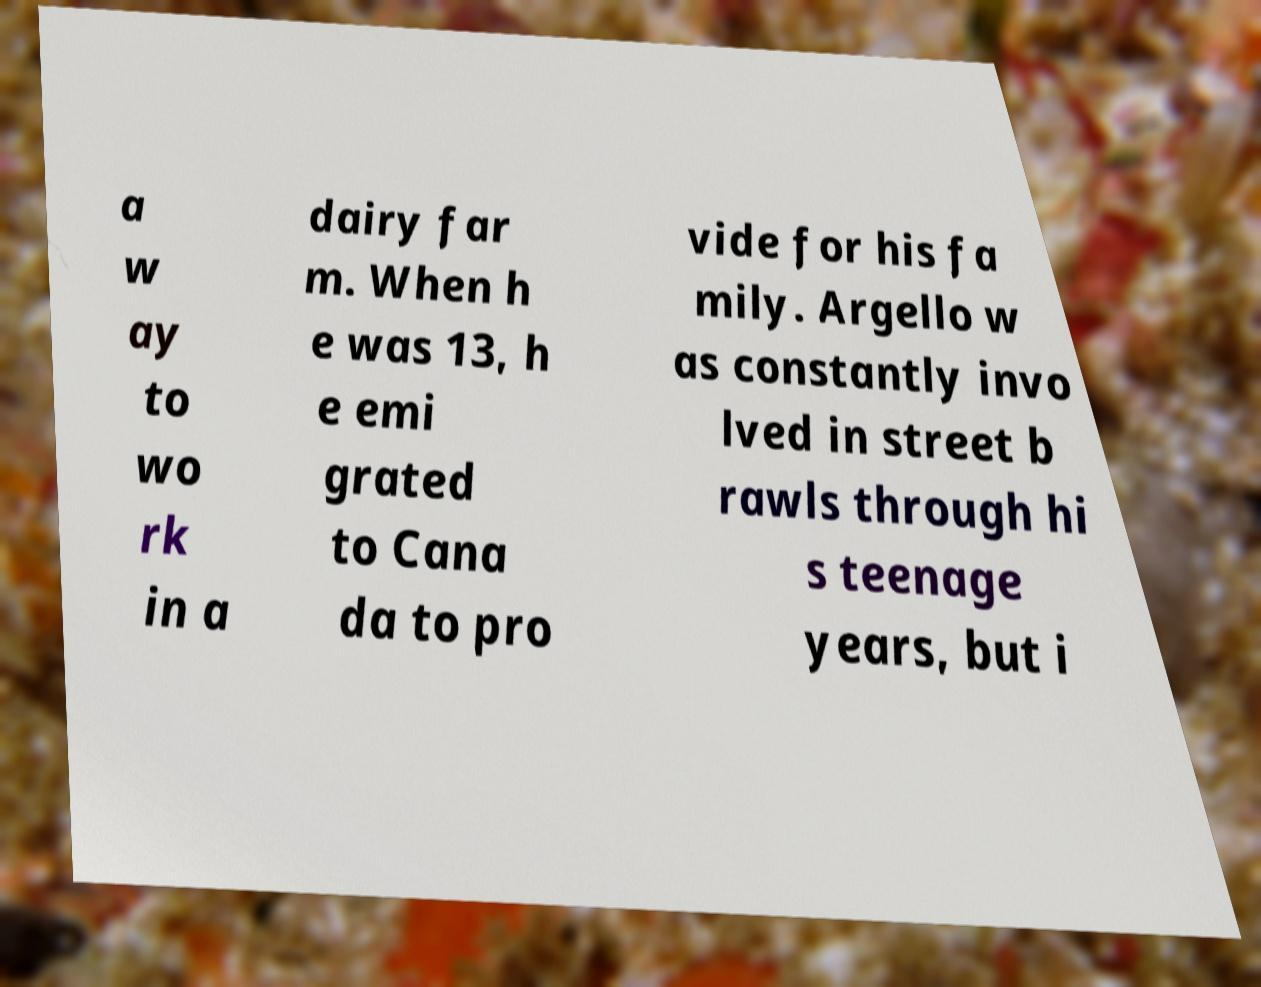There's text embedded in this image that I need extracted. Can you transcribe it verbatim? a w ay to wo rk in a dairy far m. When h e was 13, h e emi grated to Cana da to pro vide for his fa mily. Argello w as constantly invo lved in street b rawls through hi s teenage years, but i 